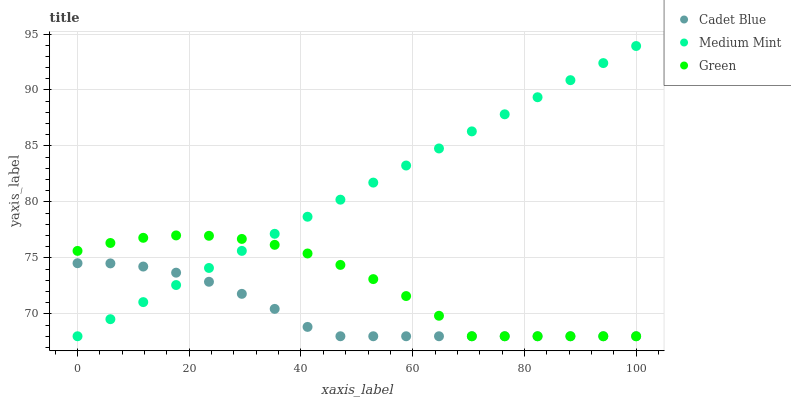Does Cadet Blue have the minimum area under the curve?
Answer yes or no. Yes. Does Medium Mint have the maximum area under the curve?
Answer yes or no. Yes. Does Green have the minimum area under the curve?
Answer yes or no. No. Does Green have the maximum area under the curve?
Answer yes or no. No. Is Medium Mint the smoothest?
Answer yes or no. Yes. Is Green the roughest?
Answer yes or no. Yes. Is Cadet Blue the smoothest?
Answer yes or no. No. Is Cadet Blue the roughest?
Answer yes or no. No. Does Medium Mint have the lowest value?
Answer yes or no. Yes. Does Medium Mint have the highest value?
Answer yes or no. Yes. Does Green have the highest value?
Answer yes or no. No. Does Medium Mint intersect Cadet Blue?
Answer yes or no. Yes. Is Medium Mint less than Cadet Blue?
Answer yes or no. No. Is Medium Mint greater than Cadet Blue?
Answer yes or no. No. 